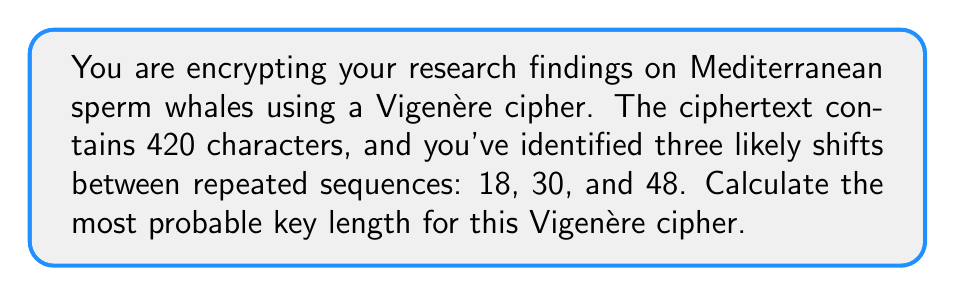Teach me how to tackle this problem. To determine the most probable key length for a Vigenère cipher, we need to find the greatest common divisor (GCD) of the identified shifts between repeated sequences. This is because the key length is likely to be a factor of these shifts.

Step 1: Identify the shifts
Given shifts: 18, 30, and 48

Step 2: Calculate the GCD
We can use the Euclidean algorithm to find the GCD:

$GCD(18, 30, 48) = GCD(GCD(18, 30), 48)$

First, calculate $GCD(18, 30)$:
$30 = 1 \times 18 + 12$
$18 = 1 \times 12 + 6$
$12 = 2 \times 6 + 0$

Therefore, $GCD(18, 30) = 6$

Now, calculate $GCD(6, 48)$:
$48 = 8 \times 6 + 0$

Therefore, the final GCD is 6.

Step 3: Verify the result
The key length should be a factor of the ciphertext length. Let's check if 6 is a factor of 420:

$420 \div 6 = 70$

Indeed, 6 is a factor of 420, confirming that it's a plausible key length.

Therefore, the most probable key length for this Vigenère cipher is 6.
Answer: 6 